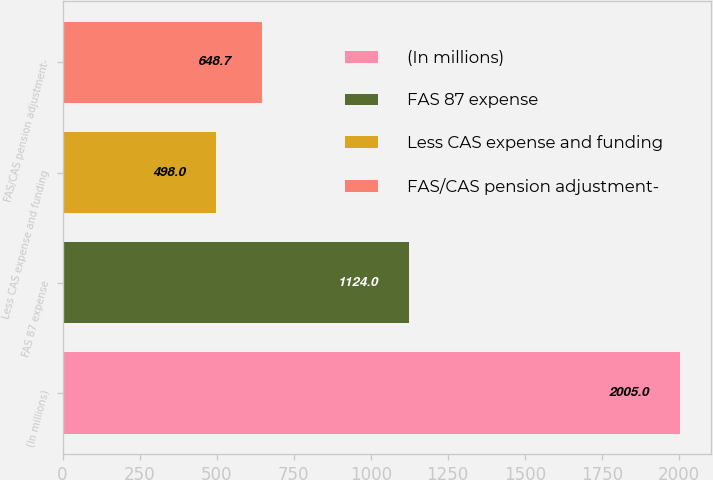Convert chart. <chart><loc_0><loc_0><loc_500><loc_500><bar_chart><fcel>(In millions)<fcel>FAS 87 expense<fcel>Less CAS expense and funding<fcel>FAS/CAS pension adjustment-<nl><fcel>2005<fcel>1124<fcel>498<fcel>648.7<nl></chart> 